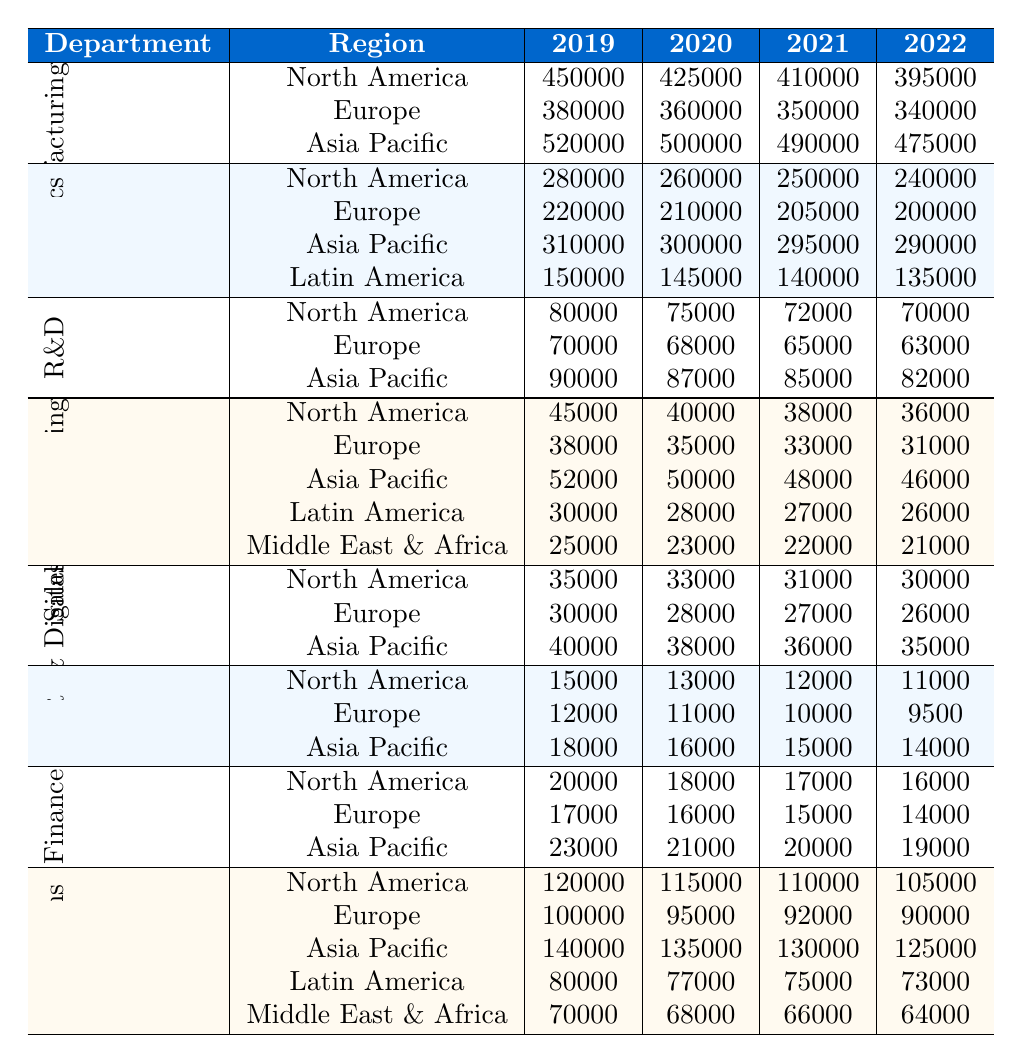What was the carbon emissions for the Manufacturing department in North America in 2020? The table shows that the emissions for the Manufacturing department in North America in 2020 is 425,000.
Answer: 425000 Which department had the highest carbon emissions in Asia Pacific for 2022? Looking at the emissions in Asia Pacific for 2022, Manufacturing had the highest emissions at 475,000 compared to Logistics (290,000), Research & Development (82,000), and others.
Answer: Manufacturing What is the total carbon emissions of the Logistics department in Latin America from 2019 to 2022? Summing the emissions for Logistics in Latin America from 2019 (150,000), 2020 (145,000), 2021 (140,000), and 2022 (135,000) gives 150,000 + 145,000 + 140,000 + 135,000 = 570,000.
Answer: 570000 What was the decrease in carbon emissions for Operations in North America from 2019 to 2022? The emissions for Operations in North America were 120,000 in 2019 and decreased to 105,000 in 2022, which is a decrease of 120,000 - 105,000 = 15,000.
Answer: 15000 Did the Research & Development department see an increase in carbon emissions in North America from 2019 to 2022? No, the emissions decreased from 80,000 in 2019 to 70,000 in 2022.
Answer: No What was the average carbon emissions for Sales & Marketing across all regions in 2022? For 2022, the emissions were 36,000 (North America), 31,000 (Europe), 46,000 (Asia Pacific), 26,000 (Latin America), and 21,000 (Middle East & Africa). The sum is 36,000 + 31,000 + 46,000 + 26,000 + 21,000 = 160,000. Dividing by 5 gives an average of 160,000 / 5 = 32,000.
Answer: 32000 Which region had the lowest carbon emissions for the Human Resources department in 2020? The table indicates that Human Resources had emissions of 13,000 in North America, 11,000 in Europe, and 16,000 in Asia Pacific in 2020. Thus, Europe had the lowest emissions at 11,000.
Answer: Europe What was the total carbon emissions for the Finance department in North America over the years 2019 to 2022? The total emissions for Finance in North America for the years 2019 (20,000), 2020 (18,000), 2021 (17,000), and 2022 (16,000) is 20,000 + 18,000 + 17,000 + 16,000 = 71,000.
Answer: 71000 Which department showed the most significant overall decrease in carbon emissions from 2019 to 2022 in Europe? By examining the emissions for each department in Europe, Manufacturing decreased from 380,000 to 340,000 (40,000), Logistics from 220,000 to 200,000 (20,000), Research & Development from 70,000 to 63,000 (7,000), Sales & Marketing from 38,000 to 31,000 (7,000), and so on. The largest decrease is seen in Manufacturing at 40,000.
Answer: Manufacturing 